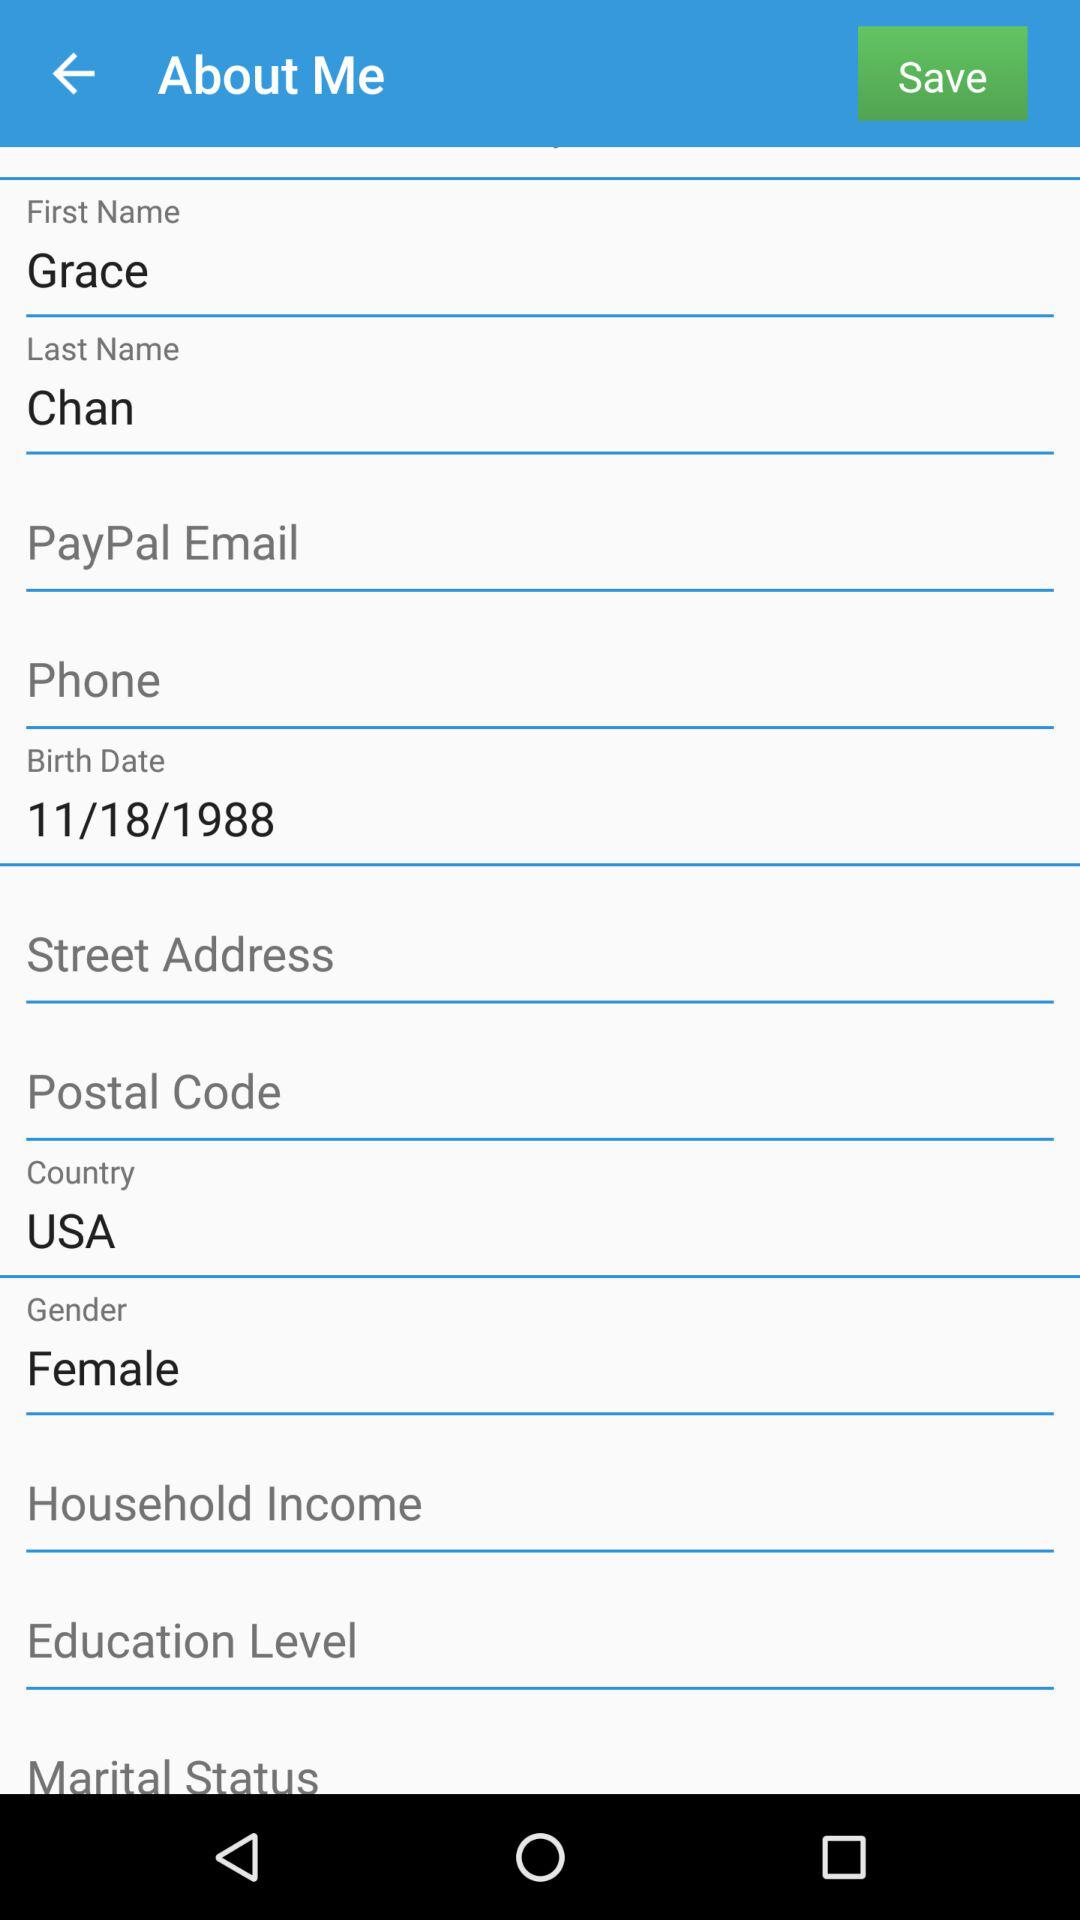What is the gender of the person? The gender of the person is female. 